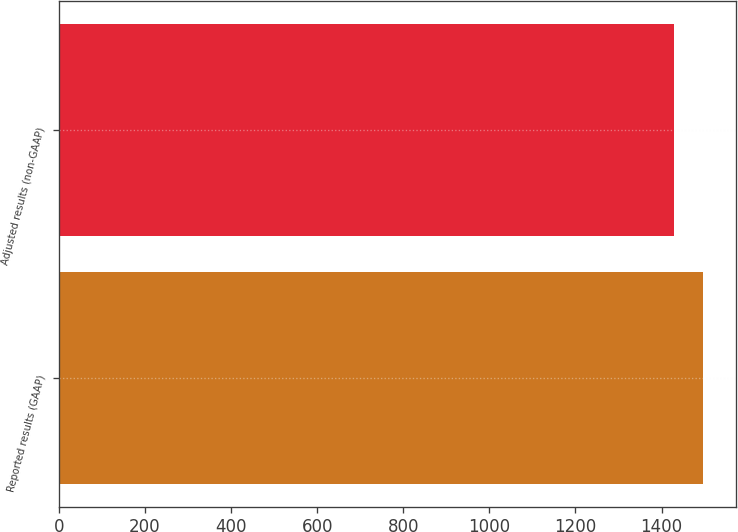<chart> <loc_0><loc_0><loc_500><loc_500><bar_chart><fcel>Reported results (GAAP)<fcel>Adjusted results (non-GAAP)<nl><fcel>1497<fcel>1430<nl></chart> 